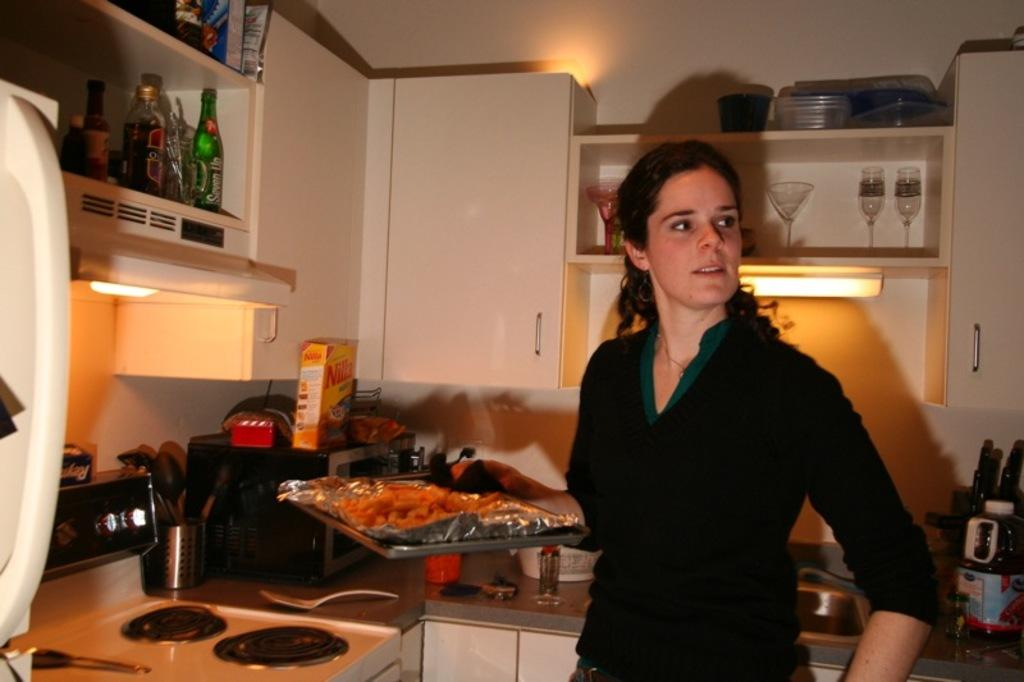<image>
Share a concise interpretation of the image provided. a woman standing in a kitchen in front of a box of 'nilla' 